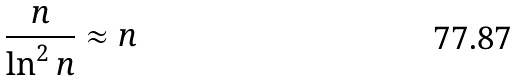Convert formula to latex. <formula><loc_0><loc_0><loc_500><loc_500>\frac { n } { \ln ^ { 2 } n } \approx n</formula> 